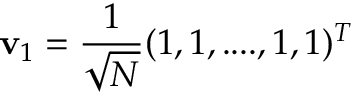<formula> <loc_0><loc_0><loc_500><loc_500>v _ { 1 } = \frac { 1 } { \sqrt { N } } ( 1 , 1 , \cdots , 1 , 1 ) ^ { T }</formula> 